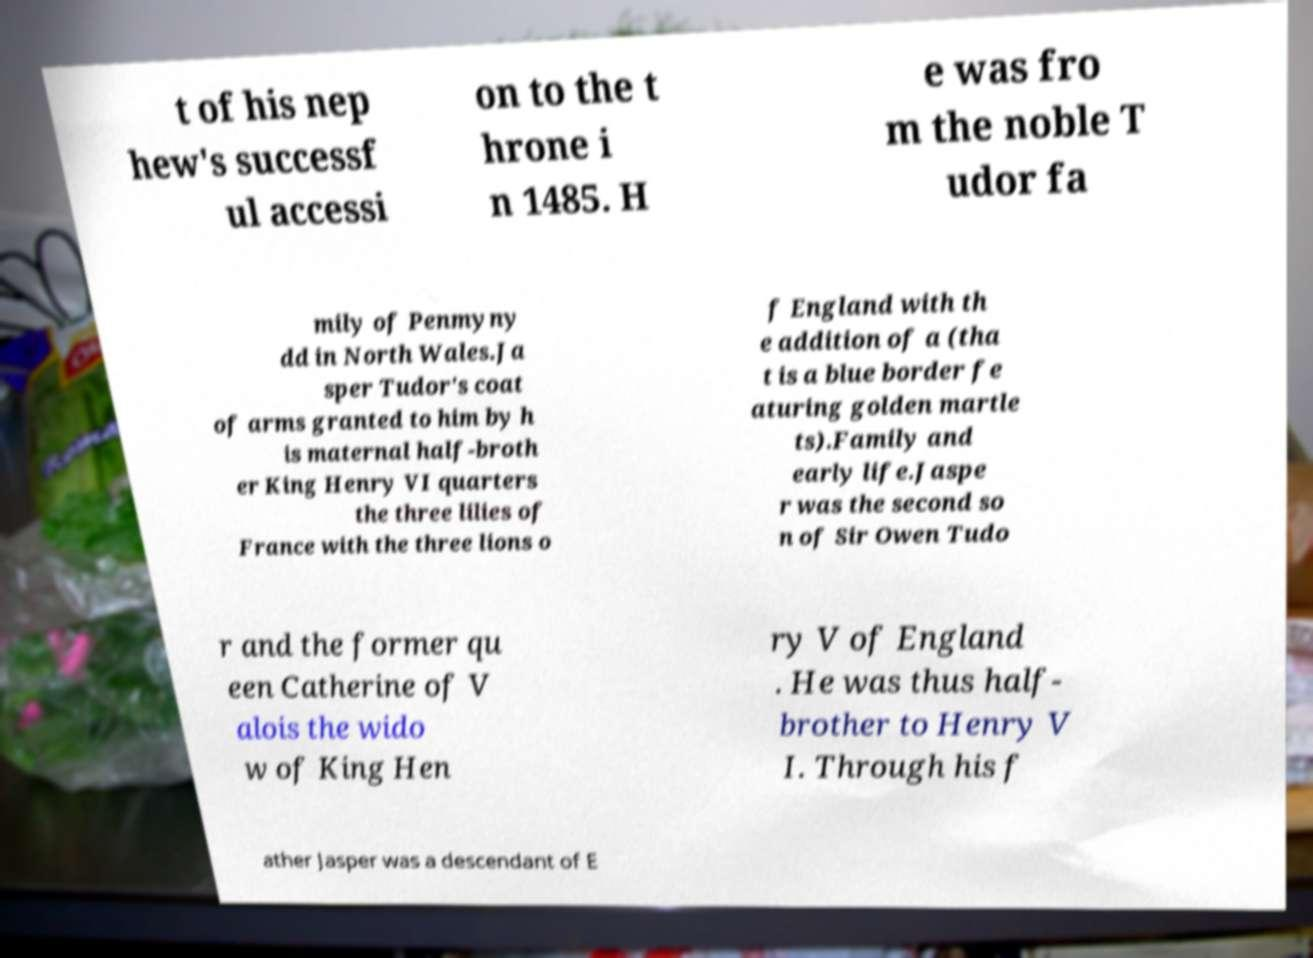There's text embedded in this image that I need extracted. Can you transcribe it verbatim? t of his nep hew's successf ul accessi on to the t hrone i n 1485. H e was fro m the noble T udor fa mily of Penmyny dd in North Wales.Ja sper Tudor's coat of arms granted to him by h is maternal half-broth er King Henry VI quarters the three lilies of France with the three lions o f England with th e addition of a (tha t is a blue border fe aturing golden martle ts).Family and early life.Jaspe r was the second so n of Sir Owen Tudo r and the former qu een Catherine of V alois the wido w of King Hen ry V of England . He was thus half- brother to Henry V I. Through his f ather Jasper was a descendant of E 